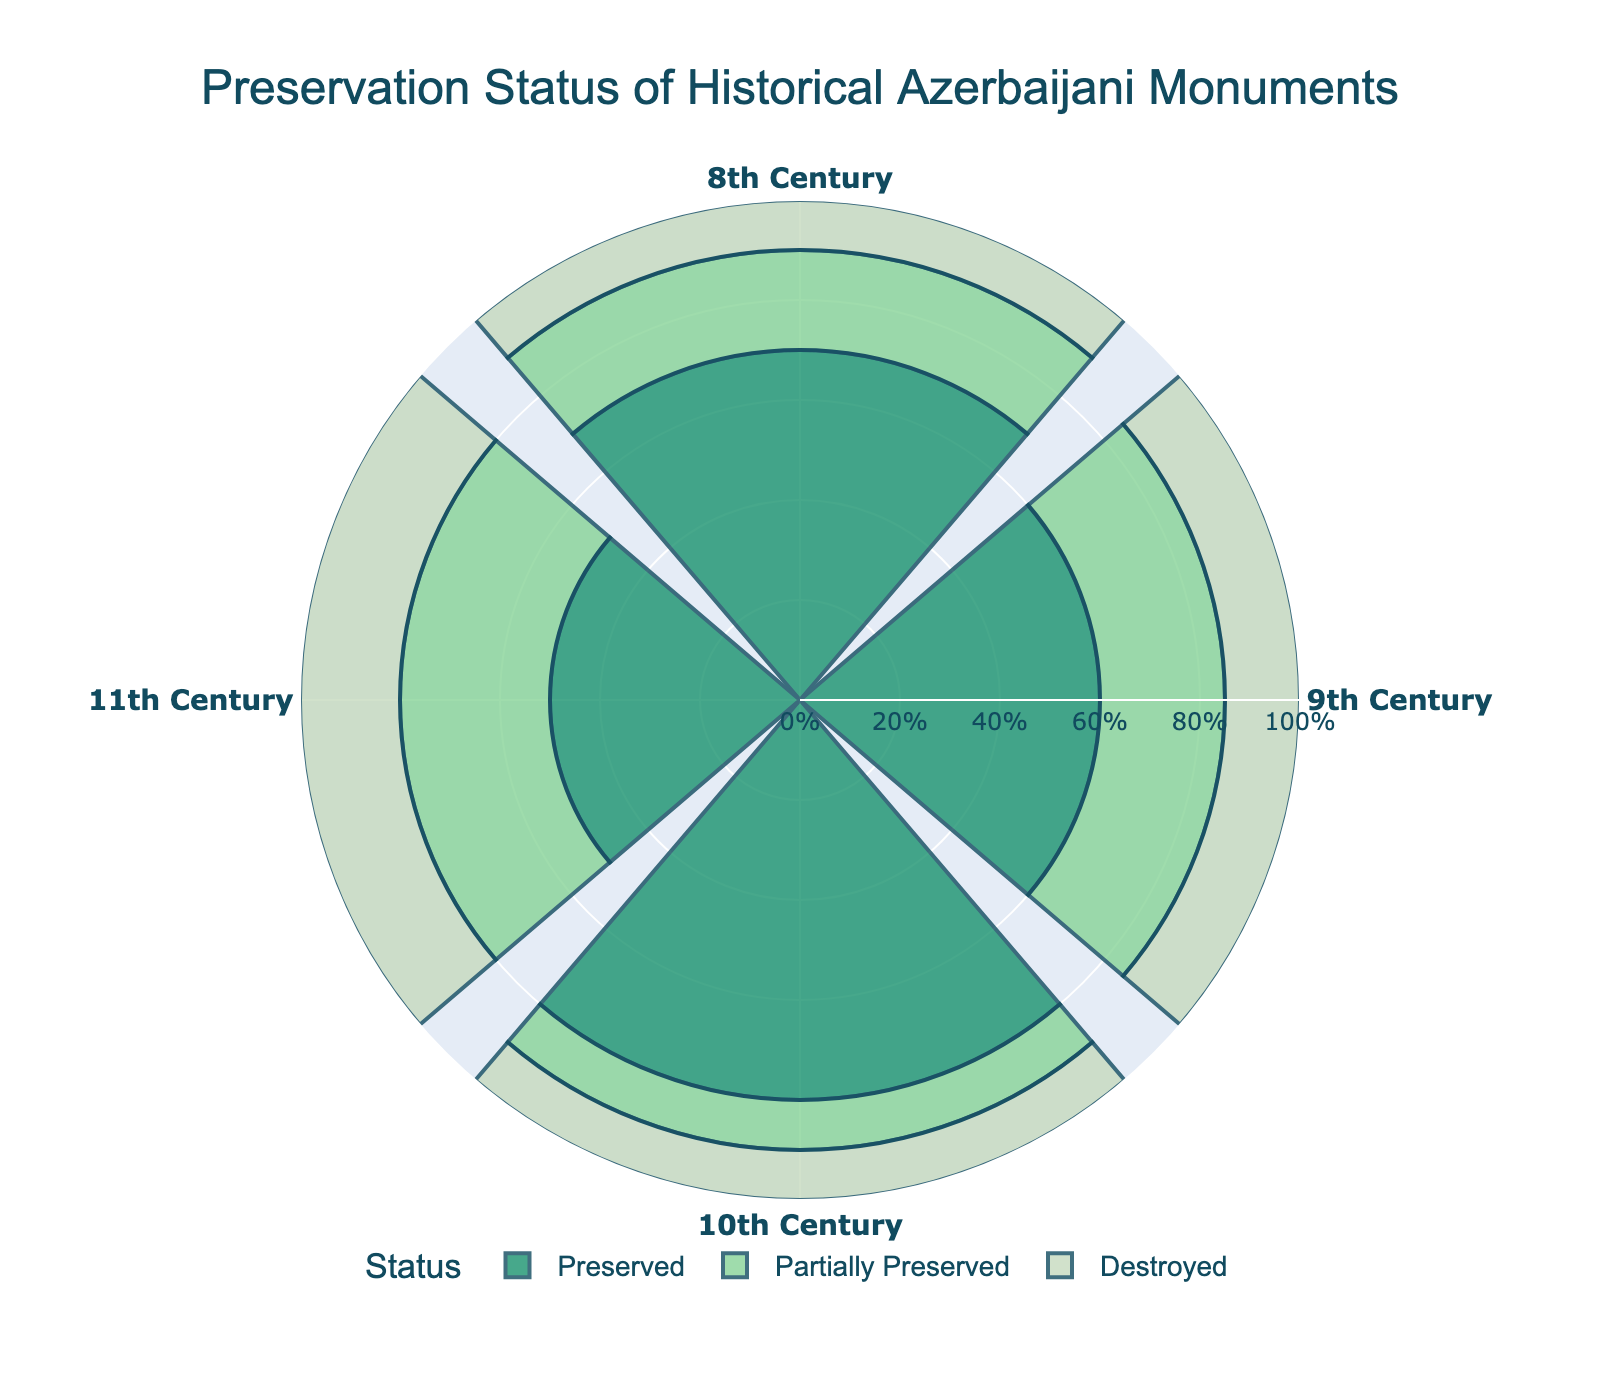How many centuries are represented in the chart? The chart includes data points representing different centuries. By counting the labels on the angular axis, we can determine the number of centuries represented. We see the labels for the 8th, 9th, 10th, and 11th centuries.
Answer: 4 Which century has the highest percentage of preserved monuments? Look at the bars corresponding to each century and identify the bar with the highest value in the 'Preserved' category. The bar for the 10th century reaches 80%, which is higher than the other centuries.
Answer: 10th Century What is the overall trend in the preservation status of the monuments from the 8th to 11th century? Compare the heights of the bars for each century across the three categories: preserved, partially preserved, and destroyed. The percentage of preserved monuments generally decreases from the 10th to the 11th century, while the percentage of partially preserved and destroyed monuments increases in the same period.
Answer: Decrease in preserved, increase in partially preserved and destroyed Between which two centuries is the difference in the percentage of destroyed monuments the greatest? Compare the percentage of destroyed monuments between each pair of centuries and identify the pair with the largest difference. The difference between the 8th century (10%) and the 11th century (20%) is the greatest.
Answer: 8th and 11th Century How does the percentage of partially preserved monuments in the 9th century compare to that in the 11th century? Look at the bars corresponding to the 'Partially Preserved' category for the 9th and 11th centuries. In the 9th century, it is 25%, and in the 11th century, it is 30%. This shows that the percentage is higher in the 11th century.
Answer: Higher in the 11th Century What is the total percentage of preserved and partially preserved monuments for the 10th century? Add the percentages of preserved and partially preserved monuments for the 10th century. The figures are 80% for preserved and 10% for partially preserved. Summing these gives 90%.
Answer: 90% Which century has the smallest percentage of preserved monuments? Identify the smallest bar in the 'Preserved' category among all centuries. The bar for the 11th century at 50% is the smallest.
Answer: 11th Century Is there a century where the percentage of destroyed monuments is equal to preserved monuments? Compare the percentage values for destroyed and preserved monuments for each century. In no century do the preservation and destruction percentages match each other.
Answer: No Considering only the 8th and 9th centuries, which century has a higher percentage of destroyed monuments? Compare the bars for destroyed monuments of the 8th and 9th centuries. The 8th century has 10% destroyed while the 9th century has 15%, so the 9th century has a higher percentage.
Answer: 9th Century Across all centuries, what is the average percentage of partially preserved monuments? Sum up the percentages of partially preserved monuments for the 8th (20%), 9th (25%), 10th (10%), and 11th (30%) centuries and then divide by the number of centuries (4). The sum is 85% and the average is 85/4 = 21.25%.
Answer: 21.25% 